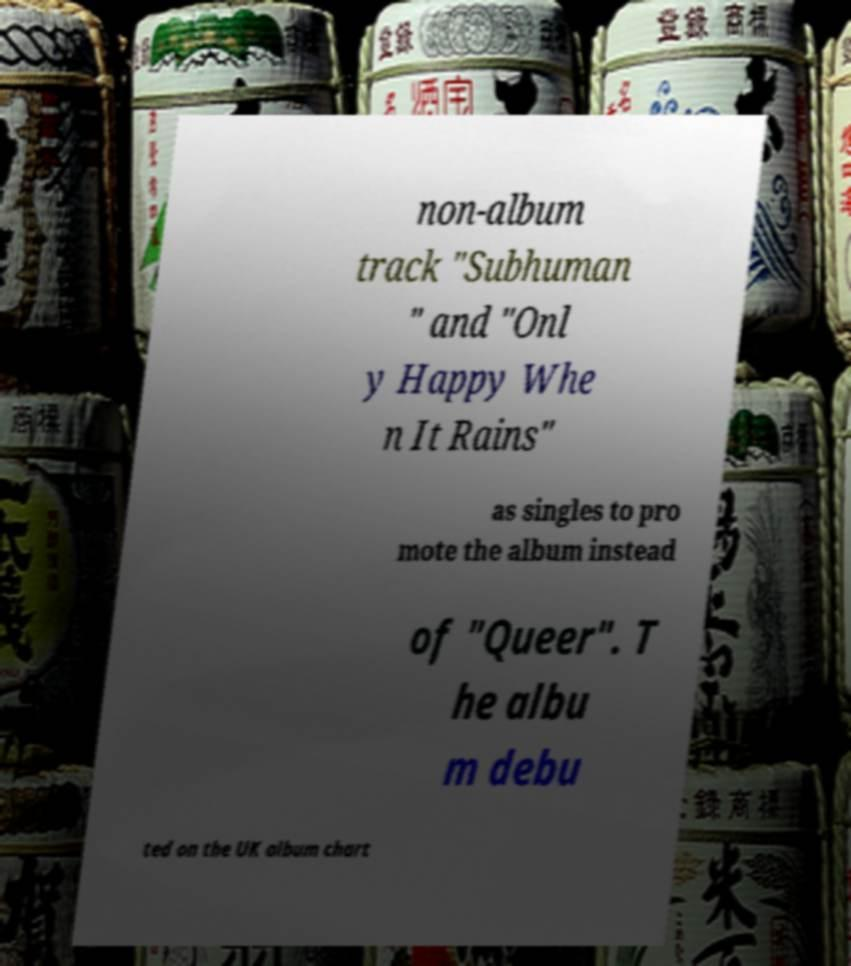What messages or text are displayed in this image? I need them in a readable, typed format. non-album track "Subhuman " and "Onl y Happy Whe n It Rains" as singles to pro mote the album instead of "Queer". T he albu m debu ted on the UK album chart 